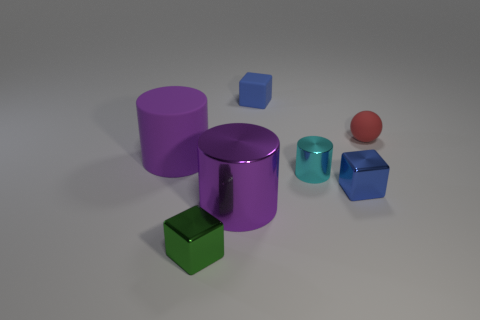Add 3 large purple cylinders. How many objects exist? 10 Subtract all cubes. How many objects are left? 4 Subtract 2 blue blocks. How many objects are left? 5 Subtract all big matte balls. Subtract all large things. How many objects are left? 5 Add 3 purple matte objects. How many purple matte objects are left? 4 Add 6 big gray metal blocks. How many big gray metal blocks exist? 6 